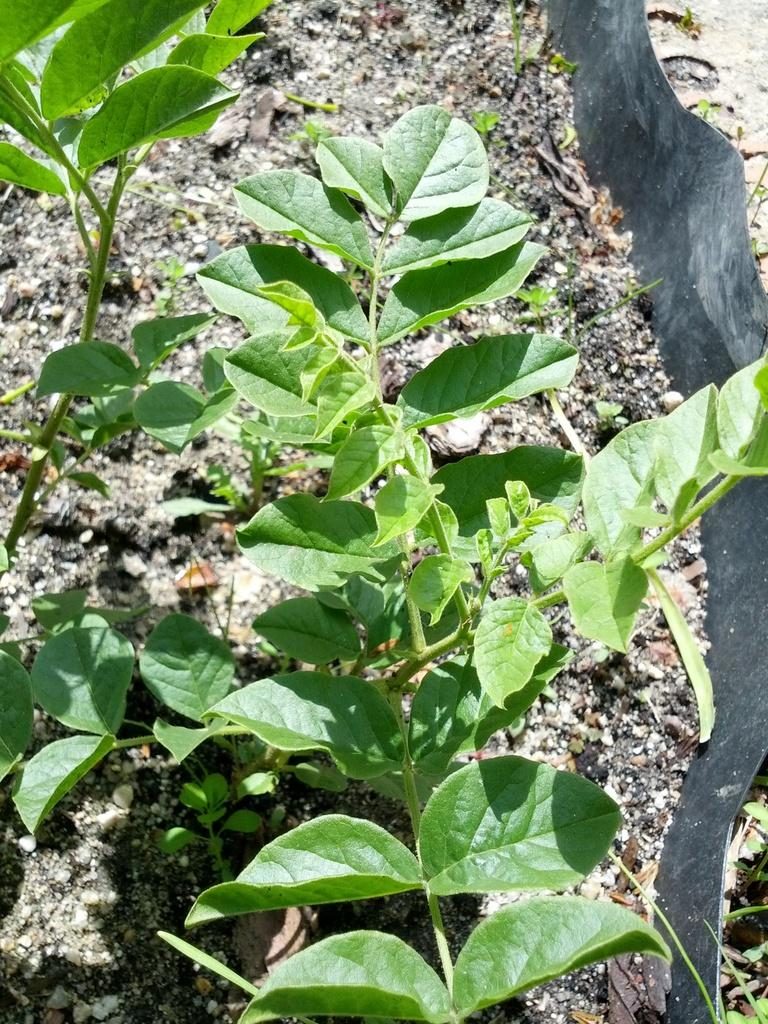What type of vegetation can be seen in the front of the image? There are plants in the front of the image. What can be seen in the background of the image? There is an object in the background of the image that is black in color. What is present on the ground in the image? Dry leaves are present on the ground can be seen in the image. How many carts are being controlled by the snakes in the image? There are no carts or snakes present in the image. 